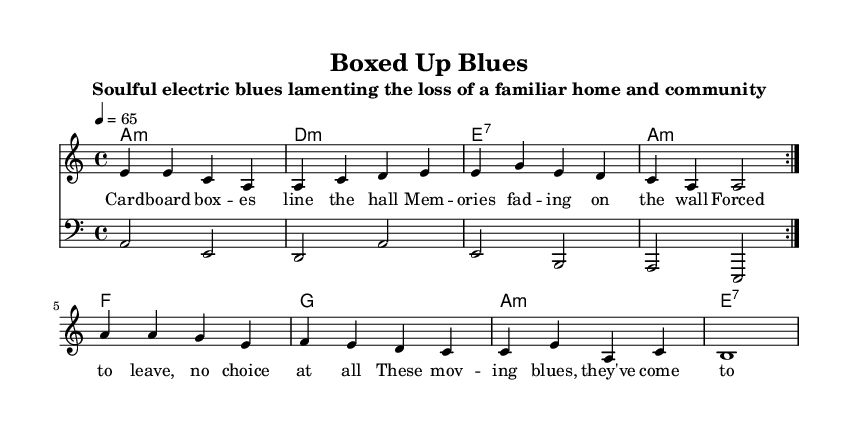What is the key signature of this music? The key signature is A minor, which has no sharps or flats. This can be identified at the beginning of the staff where the absence of any sharps or flats indicates a natural key.
Answer: A minor What is the time signature of the piece? The time signature is four-four, which is indicated at the beginning of the score by the notation "4/4". This means there are four beats in each measure and the quarter note gets one beat.
Answer: 4/4 What is the tempo marking for this music? The tempo marking is 65 beats per minute, specified in the score as "4 = 65". This indicates the speed of the piece, telling performers to aim for 65 beats in one minute.
Answer: 65 How many measures are there in the melody section? The melody section contains eight measures, as counted from the beginning of the melody line until the indicated break. Each group of four notes in the melody corresponds to one measure.
Answer: 8 What is the name of this piece? The title of the piece is "Boxed Up Blues", which is stated at the top of the score under the title header. This defines the identity of the piece for performers and the audience.
Answer: Boxed Up Blues What chords are used in the harmony section? The chords used are A minor, D minor, E seventh, F, G, and A minor. They are listed in a chord progression format under the chord names section, which indicates what harmonies support the melody.
Answer: A minor, D minor, E seventh, F, G What lyrical theme does this composition express? The lyrics reflect a theme of loss and longing for a familiar home and community, as expressed through the mournful lines about forced moving and fading memories, characteristic of Electric Blues.
Answer: Loss and longing 